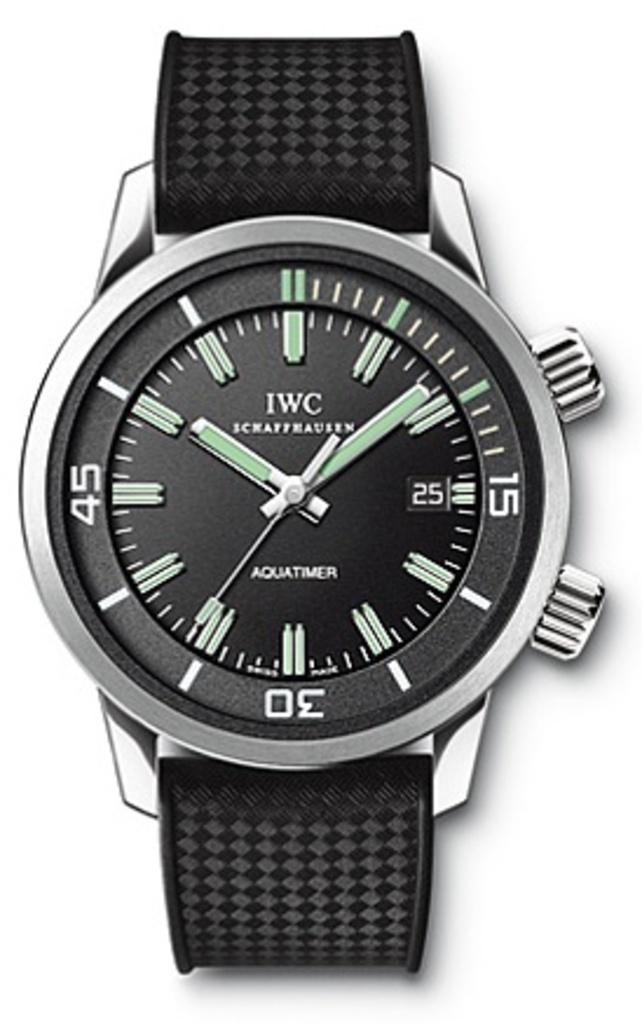<image>
Describe the image concisely. The black watch has writing on the bottom that says Aquatimer 